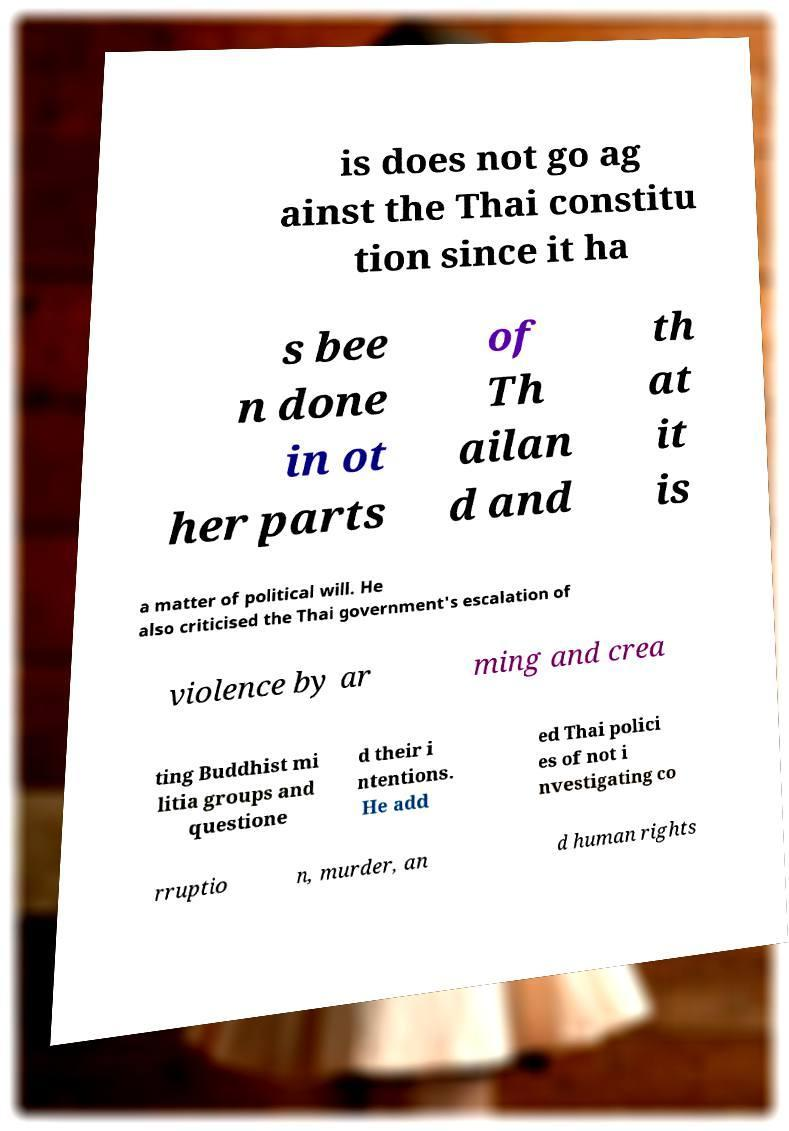Could you extract and type out the text from this image? is does not go ag ainst the Thai constitu tion since it ha s bee n done in ot her parts of Th ailan d and th at it is a matter of political will. He also criticised the Thai government's escalation of violence by ar ming and crea ting Buddhist mi litia groups and questione d their i ntentions. He add ed Thai polici es of not i nvestigating co rruptio n, murder, an d human rights 